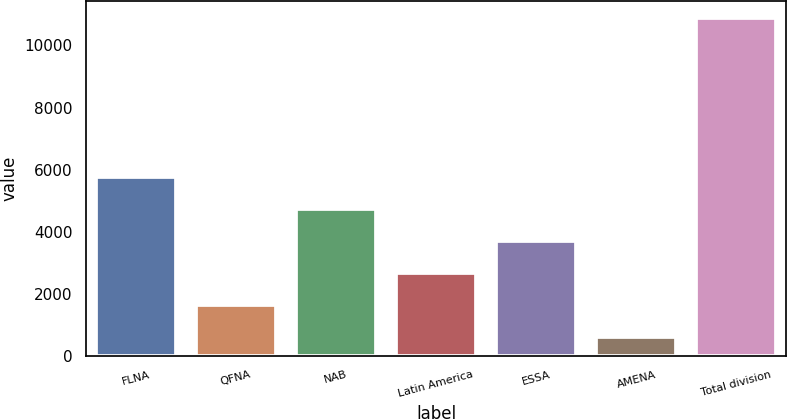Convert chart. <chart><loc_0><loc_0><loc_500><loc_500><bar_chart><fcel>FLNA<fcel>QFNA<fcel>NAB<fcel>Latin America<fcel>ESSA<fcel>AMENA<fcel>Total division<nl><fcel>5752<fcel>1645.6<fcel>4725.4<fcel>2672.2<fcel>3698.8<fcel>619<fcel>10885<nl></chart> 